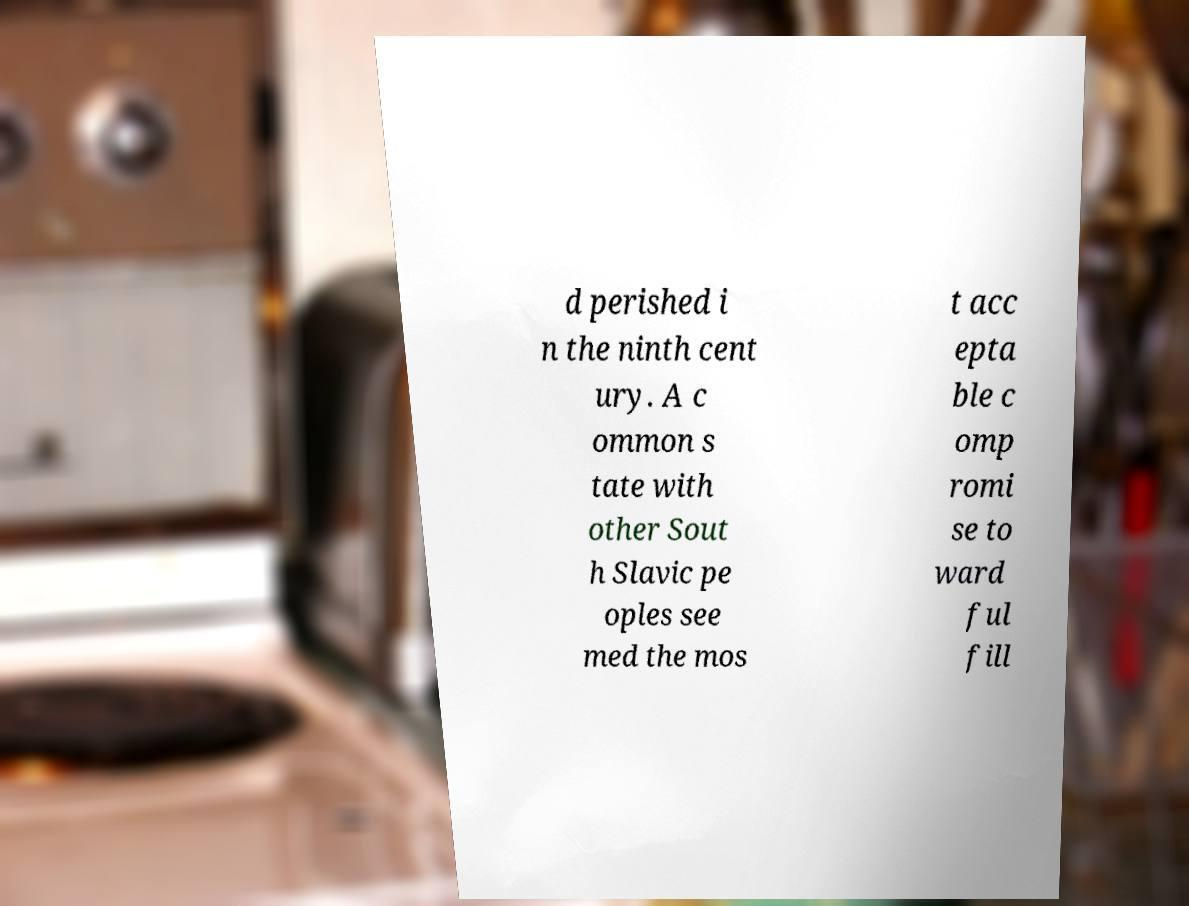What messages or text are displayed in this image? I need them in a readable, typed format. d perished i n the ninth cent ury. A c ommon s tate with other Sout h Slavic pe oples see med the mos t acc epta ble c omp romi se to ward ful fill 